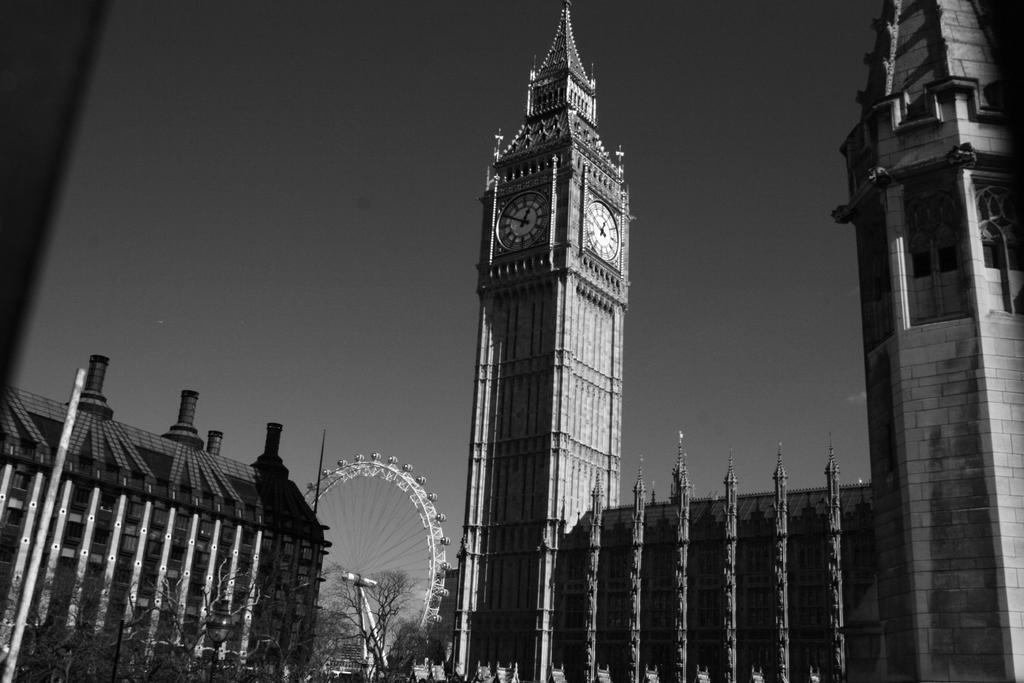Please provide a concise description of this image. In this picture I can see there are few buildings, it has a tower, with a clock, there is a giant wheel, trees and the sky is clear. 